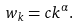Convert formula to latex. <formula><loc_0><loc_0><loc_500><loc_500>\ w _ { k } = c k ^ { \alpha } .</formula> 